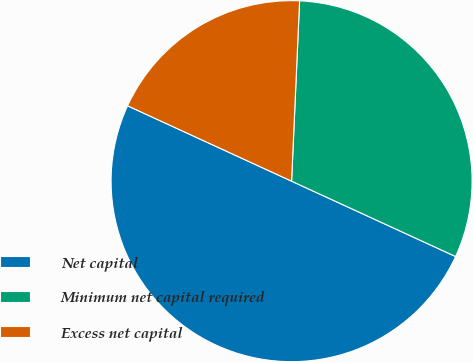<chart> <loc_0><loc_0><loc_500><loc_500><pie_chart><fcel>Net capital<fcel>Minimum net capital required<fcel>Excess net capital<nl><fcel>50.0%<fcel>31.15%<fcel>18.85%<nl></chart> 